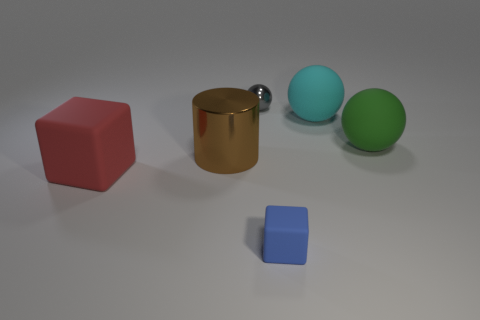Subtract all matte balls. How many balls are left? 1 Add 1 blue rubber cubes. How many objects exist? 7 Subtract all cyan spheres. How many spheres are left? 2 Subtract 1 cyan spheres. How many objects are left? 5 Subtract all cylinders. How many objects are left? 5 Subtract 1 cylinders. How many cylinders are left? 0 Subtract all blue blocks. Subtract all green spheres. How many blocks are left? 1 Subtract all brown cylinders. How many green spheres are left? 1 Subtract all small objects. Subtract all red cubes. How many objects are left? 3 Add 4 big spheres. How many big spheres are left? 6 